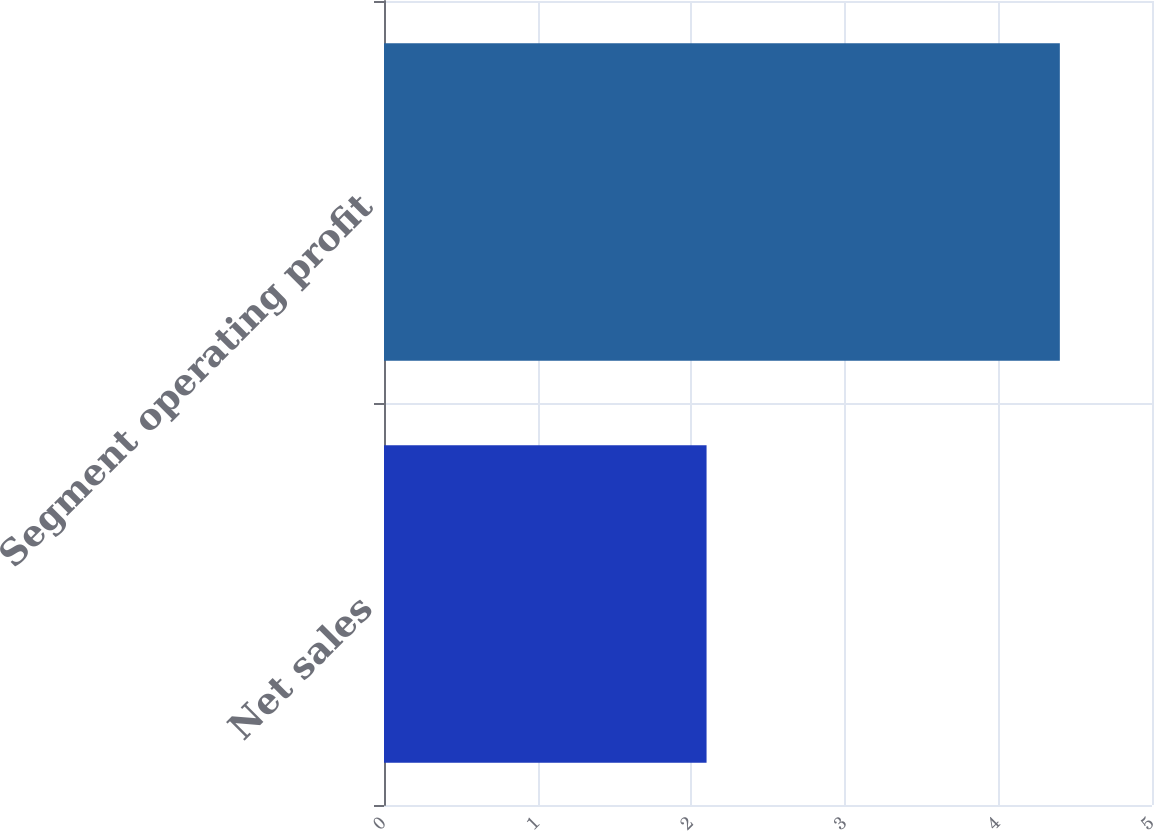Convert chart to OTSL. <chart><loc_0><loc_0><loc_500><loc_500><bar_chart><fcel>Net sales<fcel>Segment operating profit<nl><fcel>2.1<fcel>4.4<nl></chart> 